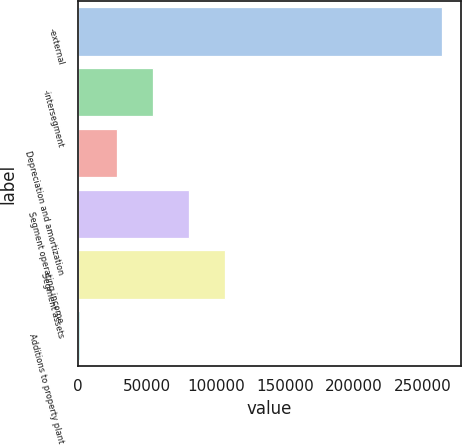Convert chart. <chart><loc_0><loc_0><loc_500><loc_500><bar_chart><fcel>-external<fcel>-intersegment<fcel>Depreciation and amortization<fcel>Segment operating income<fcel>Segment assets<fcel>Additions to property plant<nl><fcel>263922<fcel>54214.8<fcel>28001.4<fcel>80428.2<fcel>106642<fcel>1788<nl></chart> 